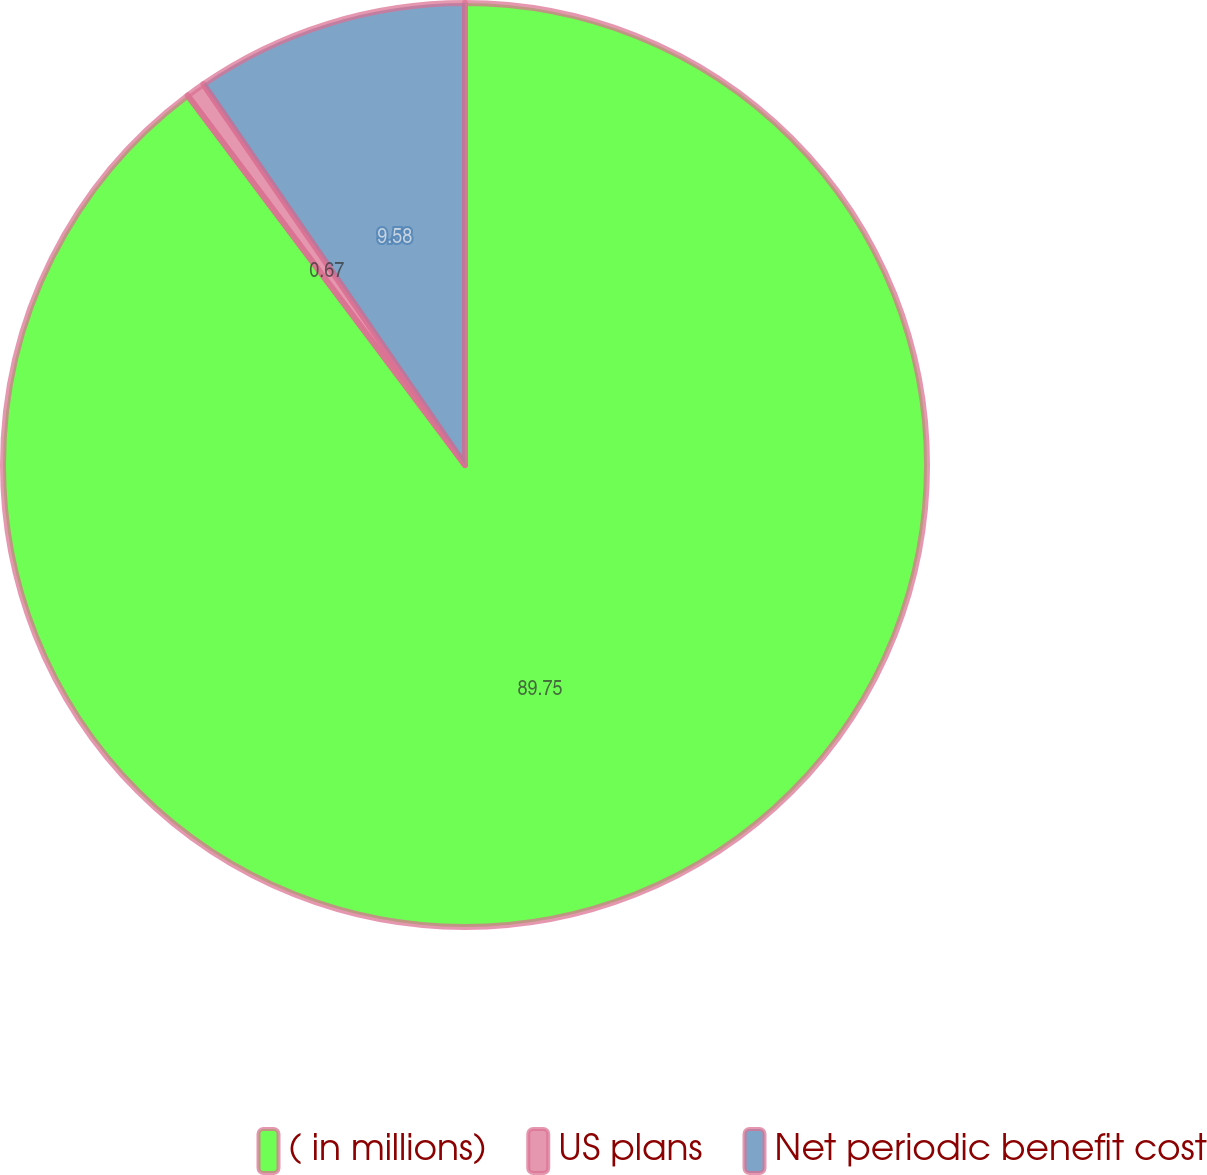Convert chart. <chart><loc_0><loc_0><loc_500><loc_500><pie_chart><fcel>( in millions)<fcel>US plans<fcel>Net periodic benefit cost<nl><fcel>89.76%<fcel>0.67%<fcel>9.58%<nl></chart> 